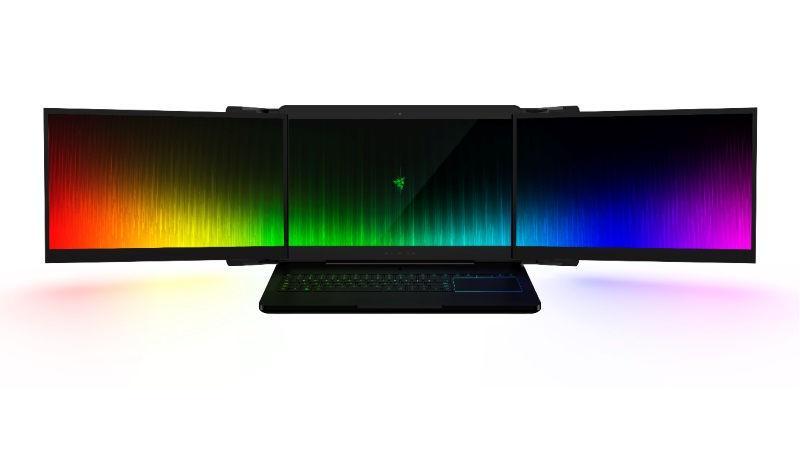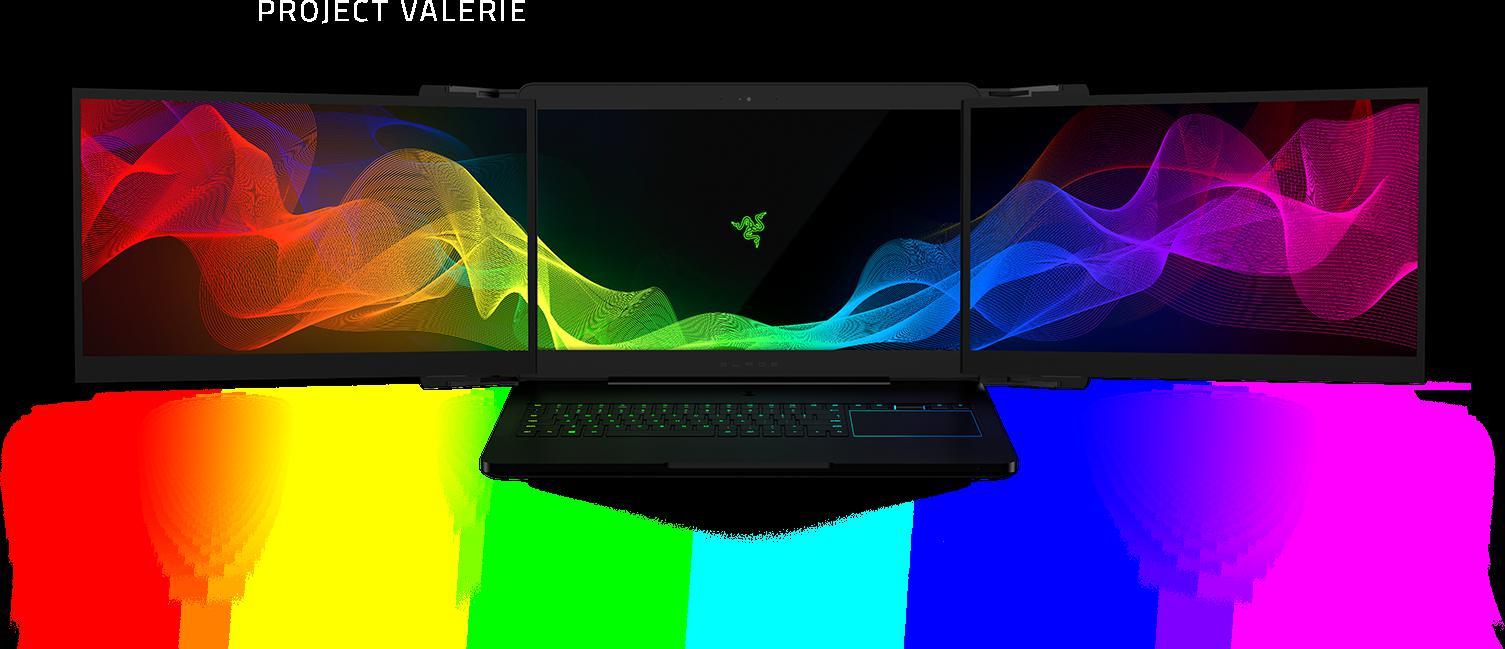The first image is the image on the left, the second image is the image on the right. Analyze the images presented: Is the assertion "At least one triple-screen laptop is displayed head-on instead of at an angle, and the three screens of at least one device create a unified image of flowing ribbons of color." valid? Answer yes or no. Yes. 